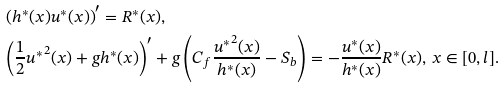<formula> <loc_0><loc_0><loc_500><loc_500>& \left ( h ^ { * } ( x ) u ^ { * } ( x ) \right ) ^ { \prime } = R ^ { * } ( x ) , \\ & \left ( \frac { 1 } { 2 } { u ^ { * } } ^ { 2 } ( x ) + g h ^ { * } ( x ) \right ) ^ { \prime } + g \left ( C _ { f } \frac { { u ^ { * } } ^ { 2 } ( x ) } { h ^ { * } ( x ) } - S _ { b } \right ) = - \frac { u ^ { * } ( x ) } { h ^ { * } ( x ) } R ^ { * } ( x ) , \, x \in [ 0 , l ] .</formula> 